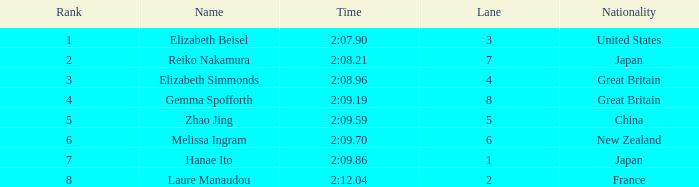What is Laure Manaudou's highest rank? 8.0. 